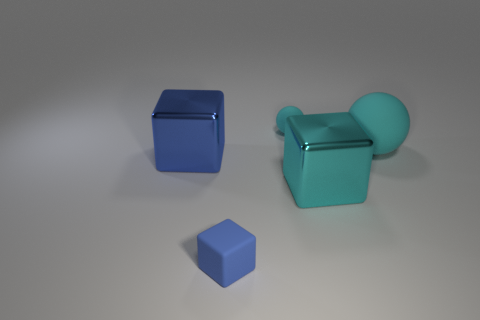Add 4 big cubes. How many objects exist? 9 Subtract all balls. How many objects are left? 3 Add 3 big blue metal things. How many big blue metal things are left? 4 Add 5 large blue things. How many large blue things exist? 6 Subtract 0 red cylinders. How many objects are left? 5 Subtract all large yellow metallic cylinders. Subtract all large cyan matte spheres. How many objects are left? 4 